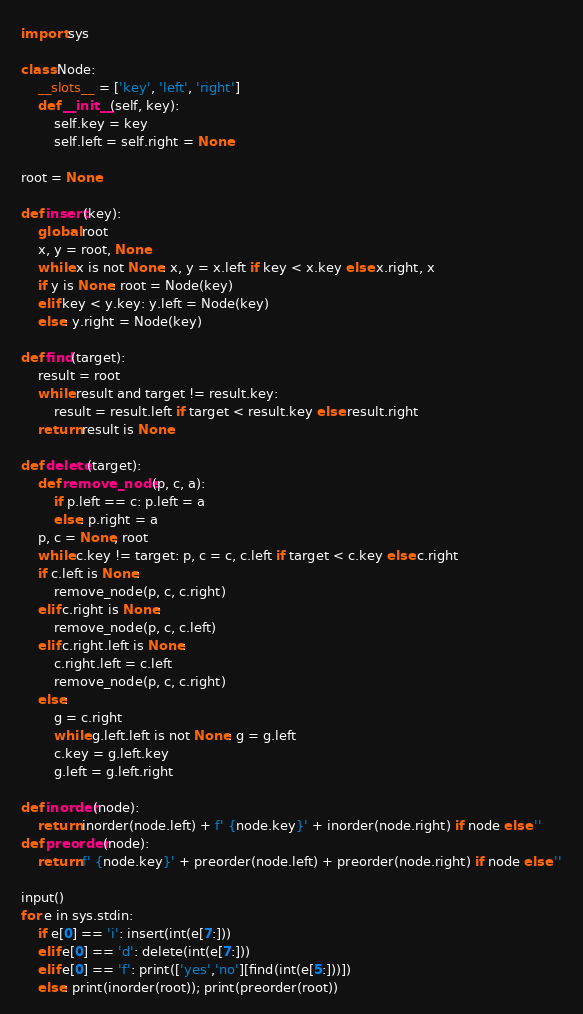<code> <loc_0><loc_0><loc_500><loc_500><_Python_>import sys

class Node:
    __slots__ = ['key', 'left', 'right']
    def __init__(self, key):
        self.key = key
        self.left = self.right = None

root = None

def insert(key):
    global root
    x, y = root, None
    while x is not None: x, y = x.left if key < x.key else x.right, x
    if y is None: root = Node(key)
    elif key < y.key: y.left = Node(key)
    else: y.right = Node(key)

def find(target):
    result = root
    while result and target != result.key:
        result = result.left if target < result.key else result.right
    return result is None

def delete(target):
    def remove_node(p, c, a):
        if p.left == c: p.left = a
        else: p.right = a
    p, c = None, root
    while c.key != target: p, c = c, c.left if target < c.key else c.right
    if c.left is None:
        remove_node(p, c, c.right)
    elif c.right is None:
        remove_node(p, c, c.left)
    elif c.right.left is None:
        c.right.left = c.left
        remove_node(p, c, c.right)
    else:
        g = c.right
        while g.left.left is not None: g = g.left
        c.key = g.left.key
        g.left = g.left.right

def inorder(node):
    return inorder(node.left) + f' {node.key}' + inorder(node.right) if node else ''
def preorder(node):
    return f' {node.key}' + preorder(node.left) + preorder(node.right) if node else ''

input()
for e in sys.stdin:
    if e[0] == 'i': insert(int(e[7:]))
    elif e[0] == 'd': delete(int(e[7:]))
    elif e[0] == 'f': print(['yes','no'][find(int(e[5:]))])
    else: print(inorder(root)); print(preorder(root))
</code> 